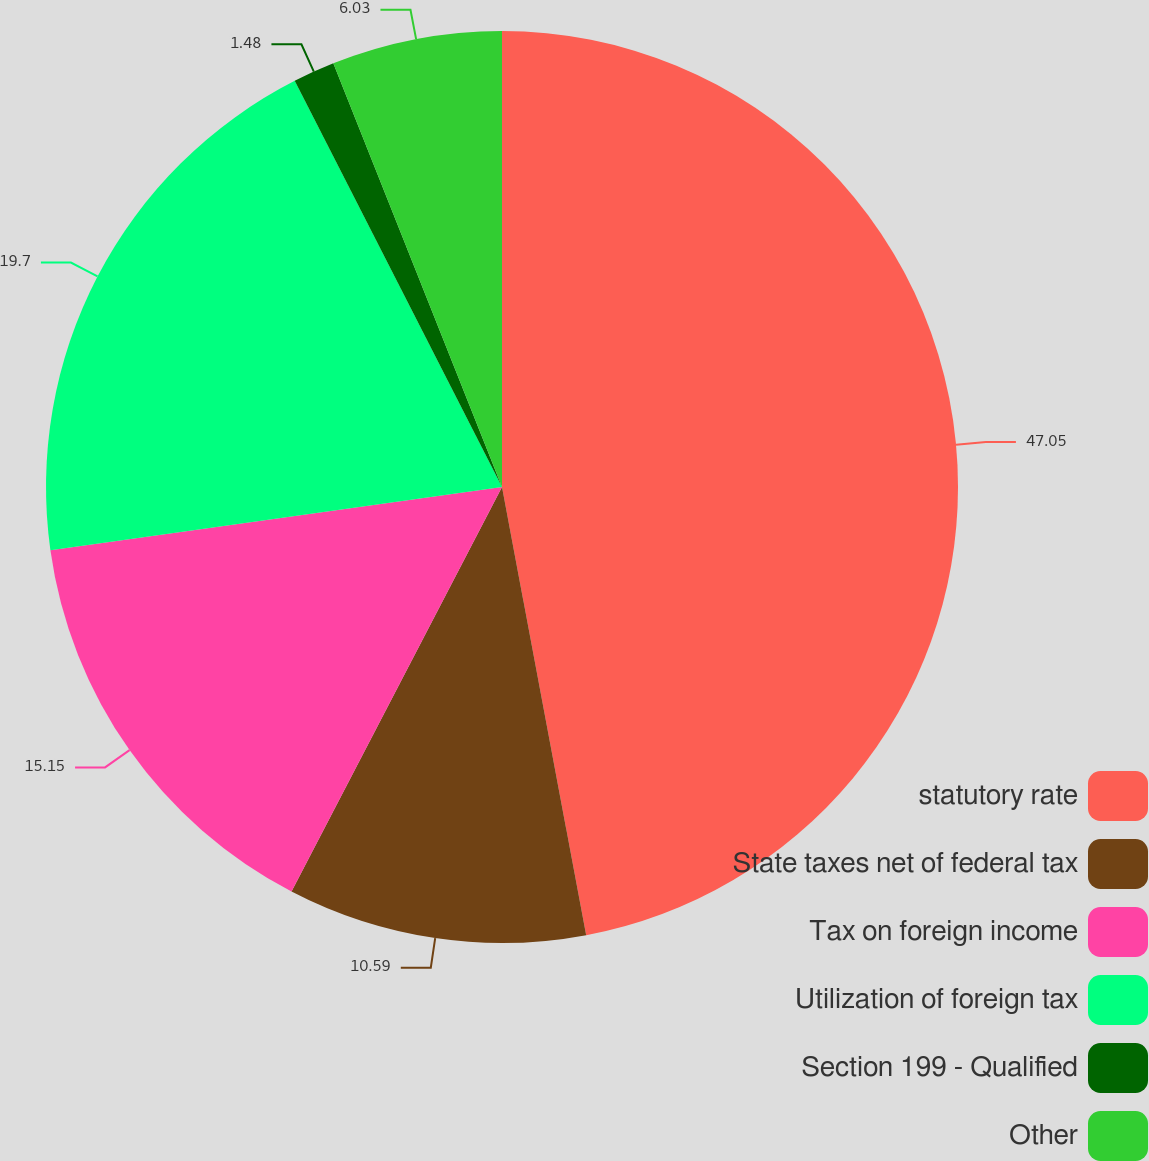Convert chart to OTSL. <chart><loc_0><loc_0><loc_500><loc_500><pie_chart><fcel>statutory rate<fcel>State taxes net of federal tax<fcel>Tax on foreign income<fcel>Utilization of foreign tax<fcel>Section 199 - Qualified<fcel>Other<nl><fcel>47.04%<fcel>10.59%<fcel>15.15%<fcel>19.7%<fcel>1.48%<fcel>6.03%<nl></chart> 